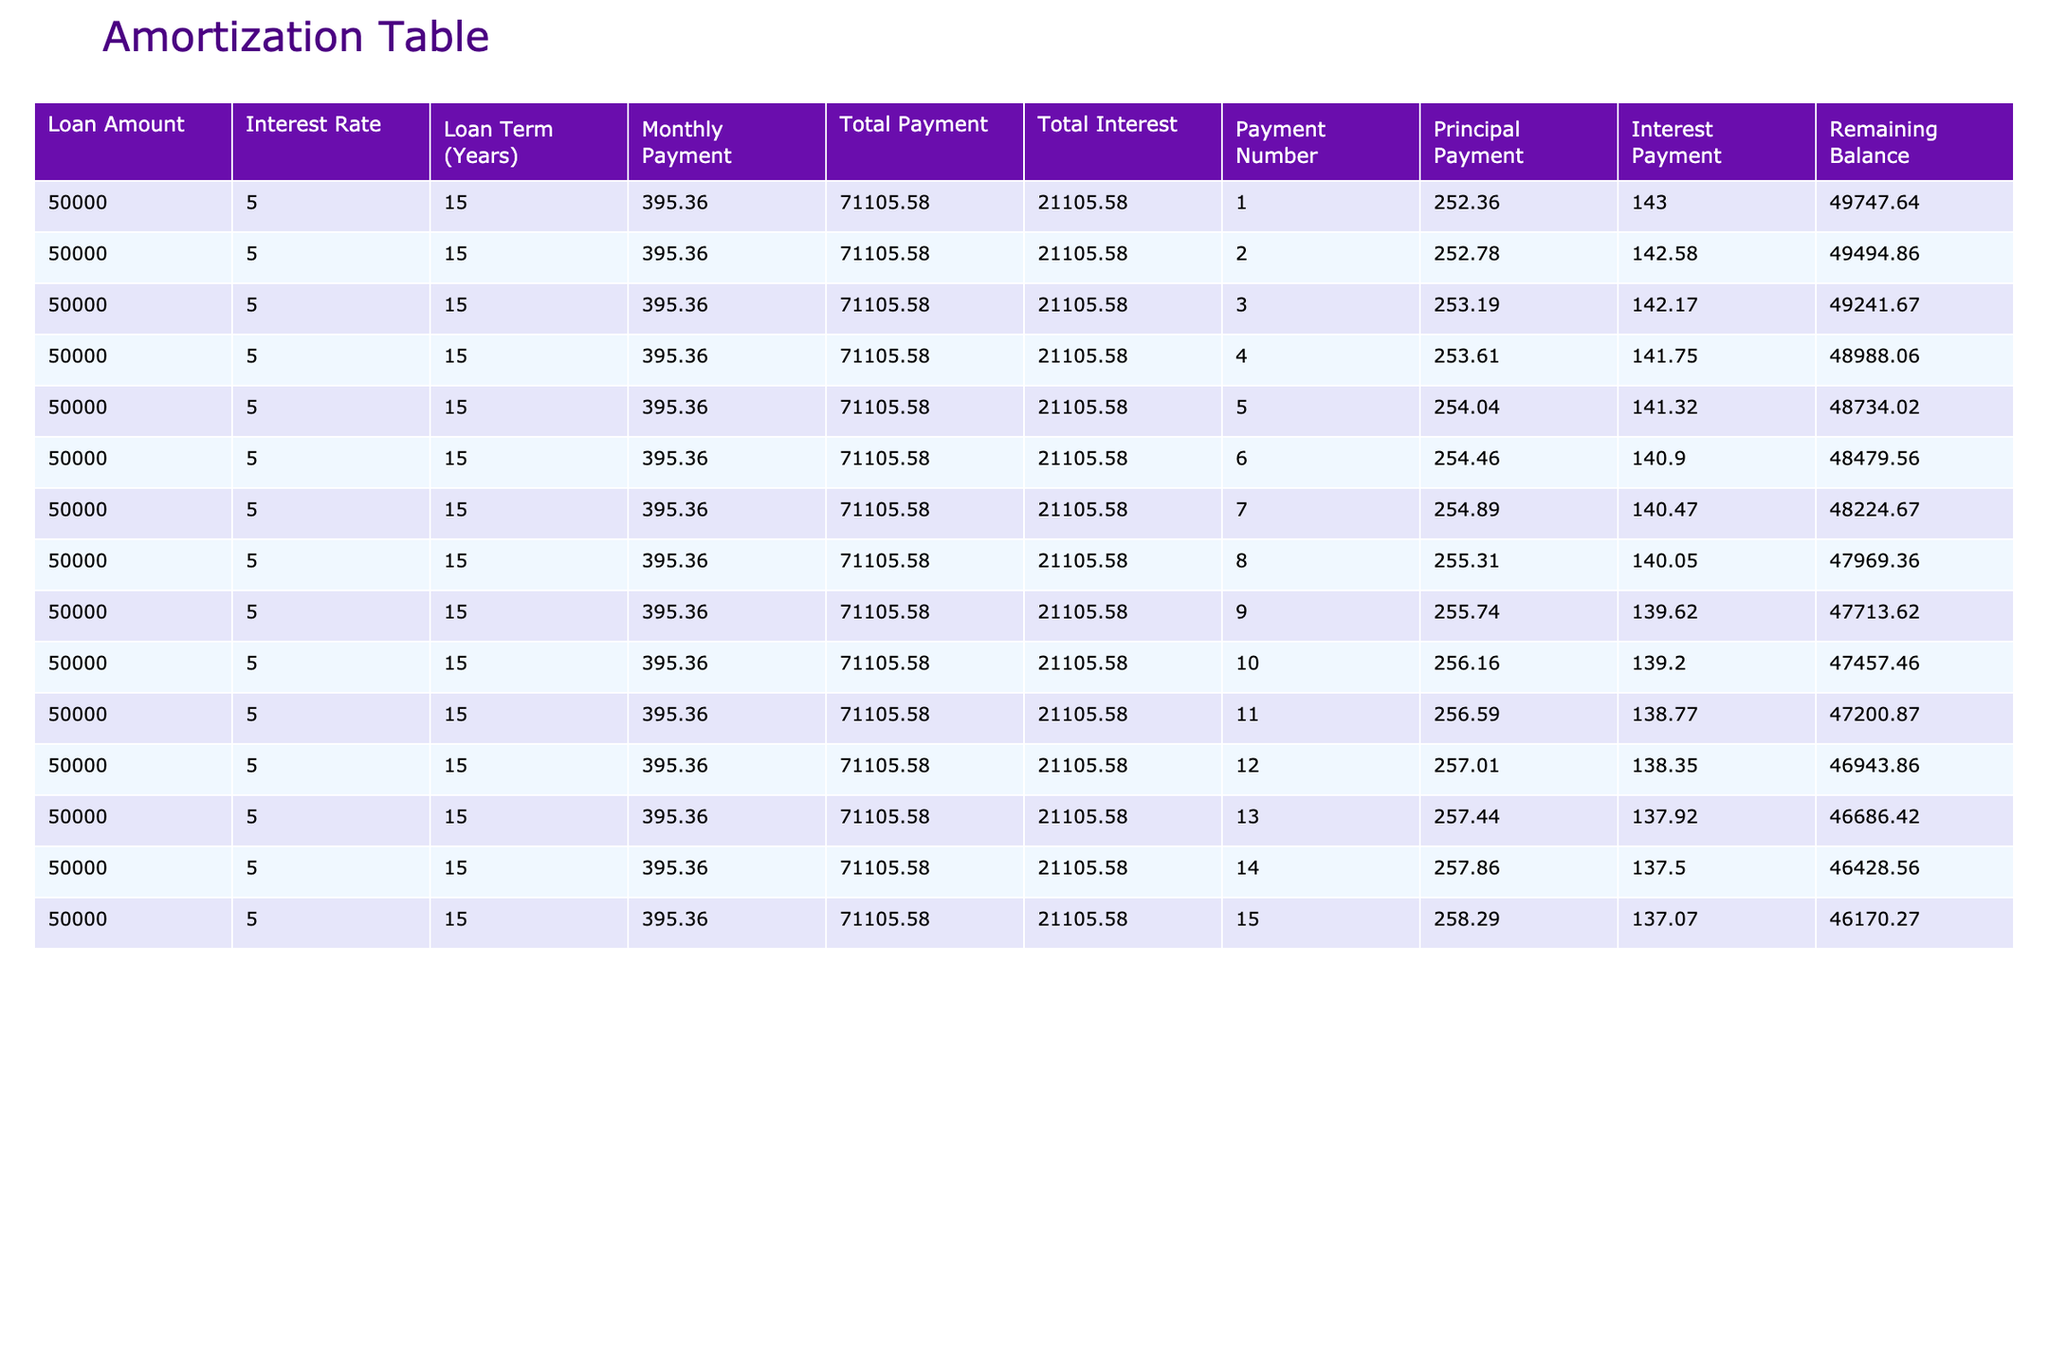What is the total amount paid over the loan term? To find the total amount paid, we look at the 'Total Payment' column for the loan term of 15 years. It shows a value of 71105.58.
Answer: 71105.58 What is the monthly payment amount? The 'Monthly Payment' row indicates that the amount to be paid each month is 395.36.
Answer: 395.36 How much interest is paid in the first month? Referring to the 'Interest Payment' column of the first row, it states the interest paid in the first month is 143.00.
Answer: 143.00 Is the principal payment higher in the first month compared to the second month? The principal payment for the first month is 252.36 while the second month shows 252.78. Since 252.78 is greater than 252.36, the statement is true.
Answer: Yes What is the average interest payment over the first five months? To determine the average interest payment, sum the interest payments for the first five months: 143.00 + 142.58 + 142.17 + 141.75 + 141.32 = 710.82. Then, divide by 5 to find the average: 710.82 / 5 = 142.164.
Answer: 142.16 What is the remaining balance after the 10th payment? The 'Remaining Balance' column indicates that after 10 payments, the remaining balance is 47457.46.
Answer: 47457.46 How much total interest is paid by the end of the loan term? The 'Total Interest' row at the end of the table shows that the total interest paid over the loan term is 21105.58.
Answer: 21105.58 Is the interest payment decreasing every month? By examining the 'Interest Payment' column, we see a consistent decrease in values from 143.00 down to 137.07, confirming that interest payments are indeed decreasing each month.
Answer: Yes What is the difference in principal payments between the first and final months? The principal payment in the first month is 252.36, and in the final month, it is 258.29. To find the difference, we subtract the first from the final: 258.29 - 252.36 = 5.93.
Answer: 5.93 